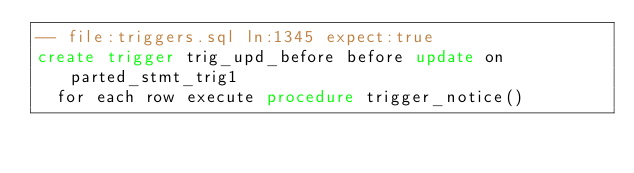<code> <loc_0><loc_0><loc_500><loc_500><_SQL_>-- file:triggers.sql ln:1345 expect:true
create trigger trig_upd_before before update on parted_stmt_trig1
  for each row execute procedure trigger_notice()
</code> 